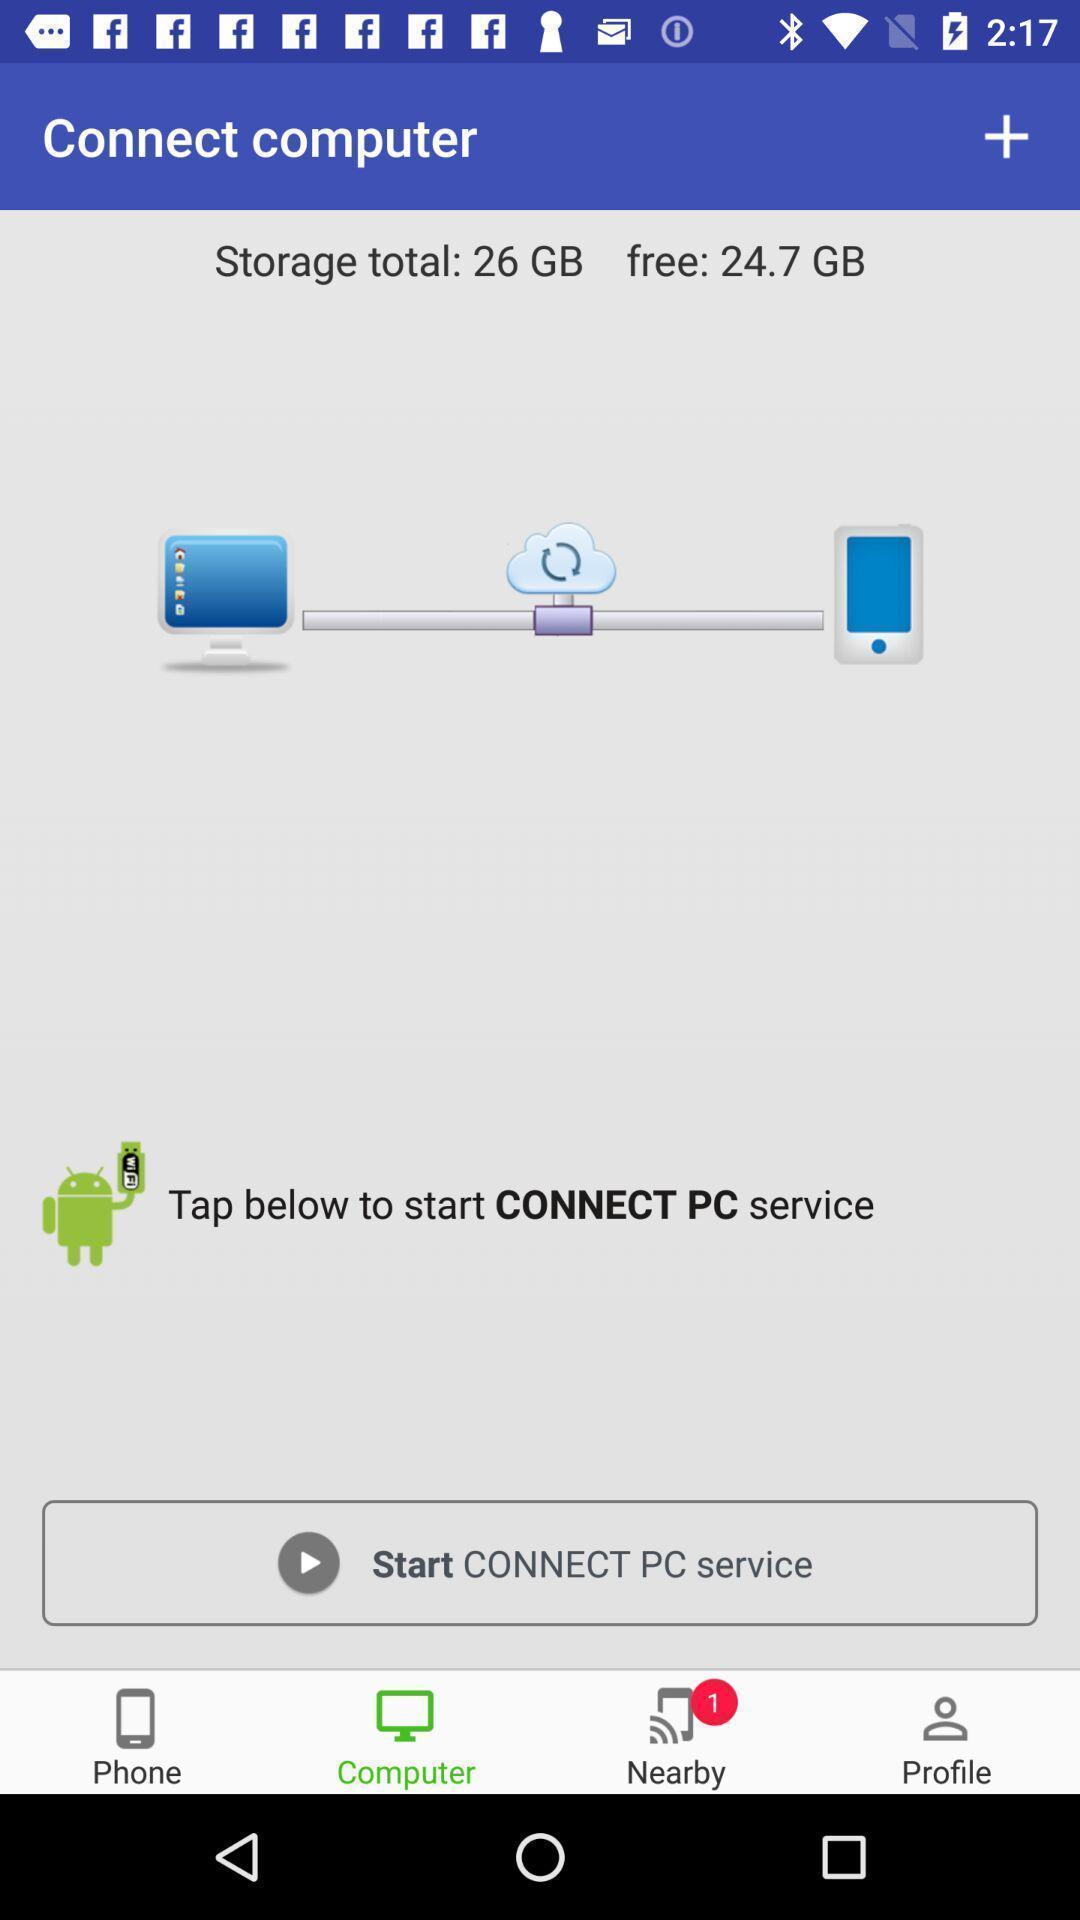Describe the visual elements of this screenshot. Page displaying the levels to connect the computer. 